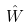Convert formula to latex. <formula><loc_0><loc_0><loc_500><loc_500>\hat { W }</formula> 